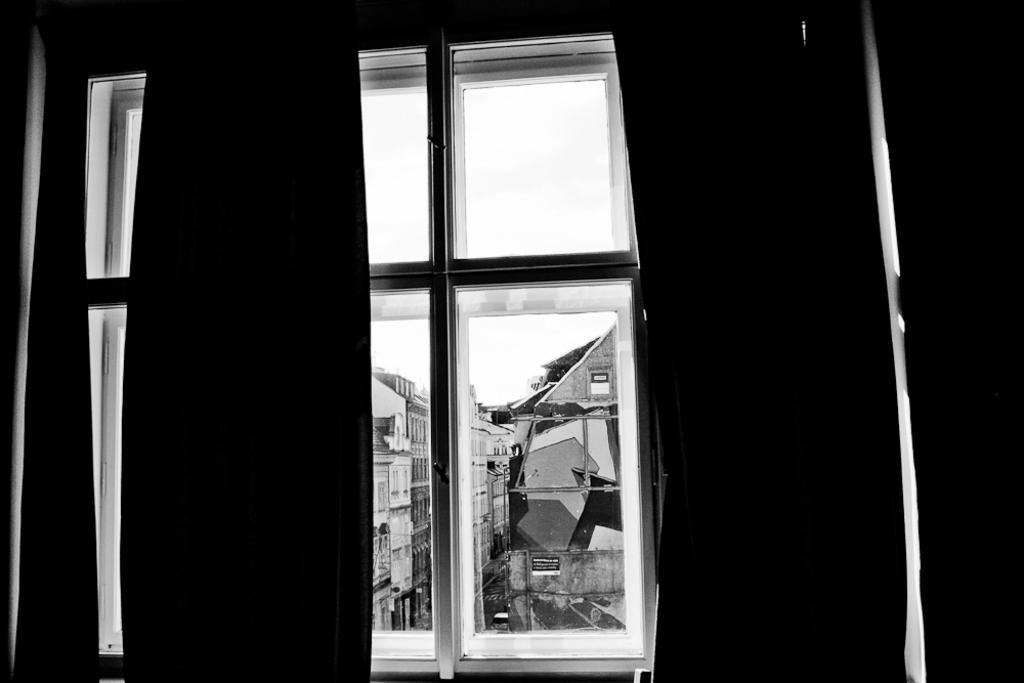Can you describe this image briefly? This is a black and white image and here we can see a wall and a window and through the window, we can see buildings and there is a vehicle on the road. At the top, there is sky. 